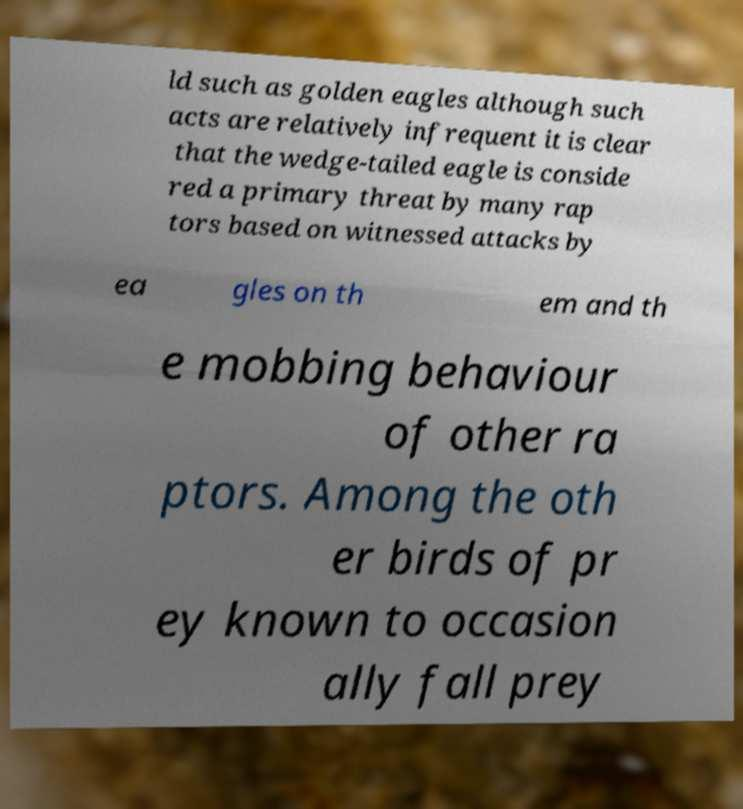There's text embedded in this image that I need extracted. Can you transcribe it verbatim? ld such as golden eagles although such acts are relatively infrequent it is clear that the wedge-tailed eagle is conside red a primary threat by many rap tors based on witnessed attacks by ea gles on th em and th e mobbing behaviour of other ra ptors. Among the oth er birds of pr ey known to occasion ally fall prey 